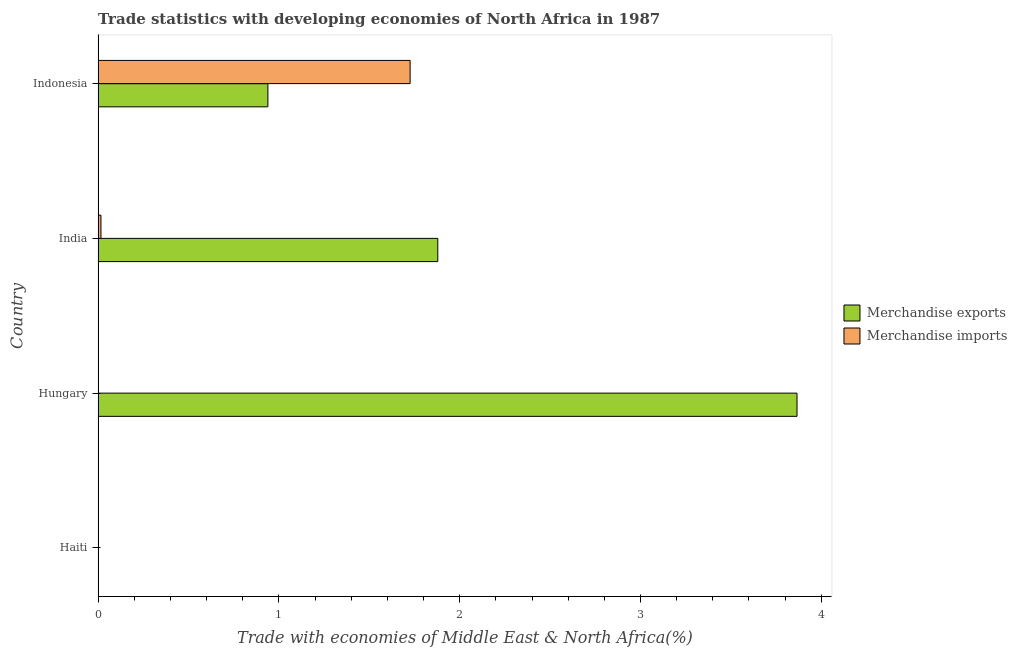How many different coloured bars are there?
Ensure brevity in your answer.  2. Are the number of bars per tick equal to the number of legend labels?
Give a very brief answer. Yes. How many bars are there on the 1st tick from the bottom?
Provide a short and direct response. 2. What is the label of the 3rd group of bars from the top?
Provide a short and direct response. Hungary. What is the merchandise imports in India?
Make the answer very short. 0.02. Across all countries, what is the maximum merchandise imports?
Provide a short and direct response. 1.73. Across all countries, what is the minimum merchandise imports?
Ensure brevity in your answer.  0. In which country was the merchandise exports minimum?
Your answer should be compact. Haiti. What is the total merchandise imports in the graph?
Your answer should be compact. 1.74. What is the difference between the merchandise exports in Hungary and that in India?
Ensure brevity in your answer.  1.99. What is the difference between the merchandise imports in Hungary and the merchandise exports in Indonesia?
Your answer should be compact. -0.94. What is the average merchandise imports per country?
Provide a short and direct response. 0.44. What is the difference between the merchandise imports and merchandise exports in Hungary?
Ensure brevity in your answer.  -3.87. What is the difference between the highest and the second highest merchandise exports?
Ensure brevity in your answer.  1.99. What is the difference between the highest and the lowest merchandise imports?
Your response must be concise. 1.73. In how many countries, is the merchandise imports greater than the average merchandise imports taken over all countries?
Ensure brevity in your answer.  1. Is the sum of the merchandise imports in Haiti and Hungary greater than the maximum merchandise exports across all countries?
Offer a terse response. No. How many bars are there?
Offer a very short reply. 8. Are all the bars in the graph horizontal?
Ensure brevity in your answer.  Yes. How many countries are there in the graph?
Ensure brevity in your answer.  4. Are the values on the major ticks of X-axis written in scientific E-notation?
Ensure brevity in your answer.  No. Does the graph contain grids?
Give a very brief answer. No. What is the title of the graph?
Ensure brevity in your answer.  Trade statistics with developing economies of North Africa in 1987. What is the label or title of the X-axis?
Your response must be concise. Trade with economies of Middle East & North Africa(%). What is the label or title of the Y-axis?
Give a very brief answer. Country. What is the Trade with economies of Middle East & North Africa(%) of Merchandise exports in Haiti?
Make the answer very short. 0. What is the Trade with economies of Middle East & North Africa(%) in Merchandise imports in Haiti?
Make the answer very short. 0. What is the Trade with economies of Middle East & North Africa(%) in Merchandise exports in Hungary?
Provide a short and direct response. 3.87. What is the Trade with economies of Middle East & North Africa(%) of Merchandise imports in Hungary?
Your answer should be very brief. 0. What is the Trade with economies of Middle East & North Africa(%) of Merchandise exports in India?
Offer a terse response. 1.88. What is the Trade with economies of Middle East & North Africa(%) in Merchandise imports in India?
Provide a short and direct response. 0.02. What is the Trade with economies of Middle East & North Africa(%) of Merchandise exports in Indonesia?
Your answer should be very brief. 0.94. What is the Trade with economies of Middle East & North Africa(%) of Merchandise imports in Indonesia?
Keep it short and to the point. 1.73. Across all countries, what is the maximum Trade with economies of Middle East & North Africa(%) in Merchandise exports?
Offer a very short reply. 3.87. Across all countries, what is the maximum Trade with economies of Middle East & North Africa(%) of Merchandise imports?
Offer a very short reply. 1.73. Across all countries, what is the minimum Trade with economies of Middle East & North Africa(%) of Merchandise exports?
Make the answer very short. 0. Across all countries, what is the minimum Trade with economies of Middle East & North Africa(%) in Merchandise imports?
Ensure brevity in your answer.  0. What is the total Trade with economies of Middle East & North Africa(%) of Merchandise exports in the graph?
Ensure brevity in your answer.  6.68. What is the total Trade with economies of Middle East & North Africa(%) in Merchandise imports in the graph?
Your answer should be very brief. 1.74. What is the difference between the Trade with economies of Middle East & North Africa(%) in Merchandise exports in Haiti and that in Hungary?
Offer a terse response. -3.86. What is the difference between the Trade with economies of Middle East & North Africa(%) of Merchandise imports in Haiti and that in Hungary?
Keep it short and to the point. 0. What is the difference between the Trade with economies of Middle East & North Africa(%) of Merchandise exports in Haiti and that in India?
Provide a succinct answer. -1.88. What is the difference between the Trade with economies of Middle East & North Africa(%) in Merchandise imports in Haiti and that in India?
Give a very brief answer. -0.01. What is the difference between the Trade with economies of Middle East & North Africa(%) of Merchandise exports in Haiti and that in Indonesia?
Make the answer very short. -0.94. What is the difference between the Trade with economies of Middle East & North Africa(%) in Merchandise imports in Haiti and that in Indonesia?
Provide a short and direct response. -1.72. What is the difference between the Trade with economies of Middle East & North Africa(%) of Merchandise exports in Hungary and that in India?
Give a very brief answer. 1.99. What is the difference between the Trade with economies of Middle East & North Africa(%) of Merchandise imports in Hungary and that in India?
Your response must be concise. -0.02. What is the difference between the Trade with economies of Middle East & North Africa(%) of Merchandise exports in Hungary and that in Indonesia?
Offer a very short reply. 2.93. What is the difference between the Trade with economies of Middle East & North Africa(%) in Merchandise imports in Hungary and that in Indonesia?
Give a very brief answer. -1.73. What is the difference between the Trade with economies of Middle East & North Africa(%) of Merchandise exports in India and that in Indonesia?
Your response must be concise. 0.94. What is the difference between the Trade with economies of Middle East & North Africa(%) of Merchandise imports in India and that in Indonesia?
Provide a succinct answer. -1.71. What is the difference between the Trade with economies of Middle East & North Africa(%) of Merchandise exports in Haiti and the Trade with economies of Middle East & North Africa(%) of Merchandise imports in Hungary?
Offer a terse response. 0. What is the difference between the Trade with economies of Middle East & North Africa(%) in Merchandise exports in Haiti and the Trade with economies of Middle East & North Africa(%) in Merchandise imports in India?
Keep it short and to the point. -0.01. What is the difference between the Trade with economies of Middle East & North Africa(%) in Merchandise exports in Haiti and the Trade with economies of Middle East & North Africa(%) in Merchandise imports in Indonesia?
Make the answer very short. -1.72. What is the difference between the Trade with economies of Middle East & North Africa(%) in Merchandise exports in Hungary and the Trade with economies of Middle East & North Africa(%) in Merchandise imports in India?
Provide a short and direct response. 3.85. What is the difference between the Trade with economies of Middle East & North Africa(%) of Merchandise exports in Hungary and the Trade with economies of Middle East & North Africa(%) of Merchandise imports in Indonesia?
Offer a very short reply. 2.14. What is the difference between the Trade with economies of Middle East & North Africa(%) of Merchandise exports in India and the Trade with economies of Middle East & North Africa(%) of Merchandise imports in Indonesia?
Offer a terse response. 0.15. What is the average Trade with economies of Middle East & North Africa(%) in Merchandise exports per country?
Your response must be concise. 1.67. What is the average Trade with economies of Middle East & North Africa(%) in Merchandise imports per country?
Ensure brevity in your answer.  0.44. What is the difference between the Trade with economies of Middle East & North Africa(%) of Merchandise exports and Trade with economies of Middle East & North Africa(%) of Merchandise imports in Haiti?
Give a very brief answer. -0. What is the difference between the Trade with economies of Middle East & North Africa(%) of Merchandise exports and Trade with economies of Middle East & North Africa(%) of Merchandise imports in Hungary?
Make the answer very short. 3.87. What is the difference between the Trade with economies of Middle East & North Africa(%) in Merchandise exports and Trade with economies of Middle East & North Africa(%) in Merchandise imports in India?
Keep it short and to the point. 1.86. What is the difference between the Trade with economies of Middle East & North Africa(%) of Merchandise exports and Trade with economies of Middle East & North Africa(%) of Merchandise imports in Indonesia?
Your response must be concise. -0.79. What is the ratio of the Trade with economies of Middle East & North Africa(%) of Merchandise imports in Haiti to that in Hungary?
Make the answer very short. 7.33. What is the ratio of the Trade with economies of Middle East & North Africa(%) of Merchandise exports in Haiti to that in India?
Your answer should be compact. 0. What is the ratio of the Trade with economies of Middle East & North Africa(%) of Merchandise imports in Haiti to that in India?
Your answer should be very brief. 0.12. What is the ratio of the Trade with economies of Middle East & North Africa(%) in Merchandise exports in Haiti to that in Indonesia?
Make the answer very short. 0. What is the ratio of the Trade with economies of Middle East & North Africa(%) in Merchandise imports in Haiti to that in Indonesia?
Keep it short and to the point. 0. What is the ratio of the Trade with economies of Middle East & North Africa(%) of Merchandise exports in Hungary to that in India?
Provide a short and direct response. 2.06. What is the ratio of the Trade with economies of Middle East & North Africa(%) of Merchandise imports in Hungary to that in India?
Provide a succinct answer. 0.02. What is the ratio of the Trade with economies of Middle East & North Africa(%) in Merchandise exports in Hungary to that in Indonesia?
Give a very brief answer. 4.12. What is the ratio of the Trade with economies of Middle East & North Africa(%) of Merchandise exports in India to that in Indonesia?
Provide a succinct answer. 2. What is the ratio of the Trade with economies of Middle East & North Africa(%) in Merchandise imports in India to that in Indonesia?
Provide a short and direct response. 0.01. What is the difference between the highest and the second highest Trade with economies of Middle East & North Africa(%) in Merchandise exports?
Keep it short and to the point. 1.99. What is the difference between the highest and the second highest Trade with economies of Middle East & North Africa(%) in Merchandise imports?
Ensure brevity in your answer.  1.71. What is the difference between the highest and the lowest Trade with economies of Middle East & North Africa(%) in Merchandise exports?
Make the answer very short. 3.86. What is the difference between the highest and the lowest Trade with economies of Middle East & North Africa(%) in Merchandise imports?
Offer a terse response. 1.73. 